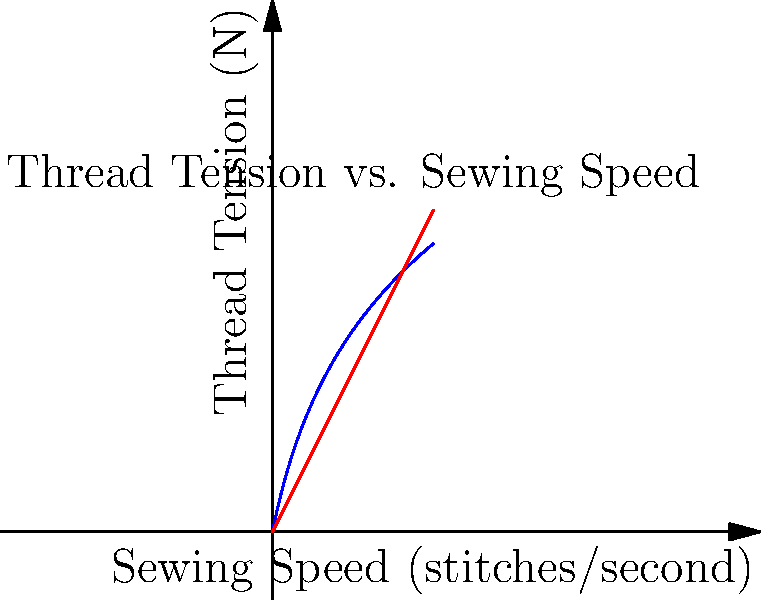The graph shows the relationship between thread tension and sewing speed for our latest sewing machine model. The blue curve represents thread tension, and the red line represents sewing speed. If the thread tension $T$ (in Newtons) is given by the function $T(s) = 5\ln(s+1)$, where $s$ is the sewing speed in stitches per second, what is the rate of change of thread tension when the sewing speed is 4 stitches per second? To find the rate of change of thread tension at a specific sewing speed, we need to calculate the derivative of the tension function and evaluate it at the given speed.

Step 1: The thread tension function is $T(s) = 5\ln(s+1)$.

Step 2: Calculate the derivative of $T(s)$ using the chain rule:
$$\frac{dT}{ds} = 5 \cdot \frac{d}{ds}[\ln(s+1)] = 5 \cdot \frac{1}{s+1}$$

Step 3: Evaluate the derivative at $s = 4$:
$$\frac{dT}{ds}\bigg|_{s=4} = 5 \cdot \frac{1}{4+1} = 5 \cdot \frac{1}{5} = 1$$

Therefore, when the sewing speed is 4 stitches per second, the rate of change of thread tension is 1 Newton per stitch per second.
Answer: 1 N/(stitch/s) 